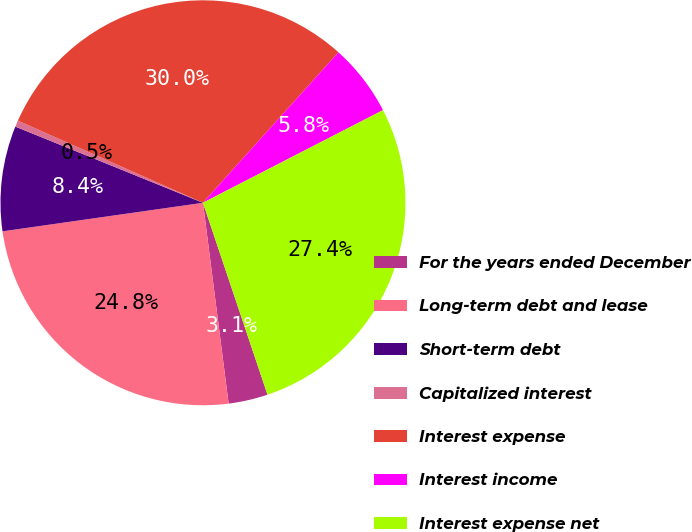Convert chart. <chart><loc_0><loc_0><loc_500><loc_500><pie_chart><fcel>For the years ended December<fcel>Long-term debt and lease<fcel>Short-term debt<fcel>Capitalized interest<fcel>Interest expense<fcel>Interest income<fcel>Interest expense net<nl><fcel>3.14%<fcel>24.77%<fcel>8.39%<fcel>0.51%<fcel>30.02%<fcel>5.77%<fcel>27.4%<nl></chart> 